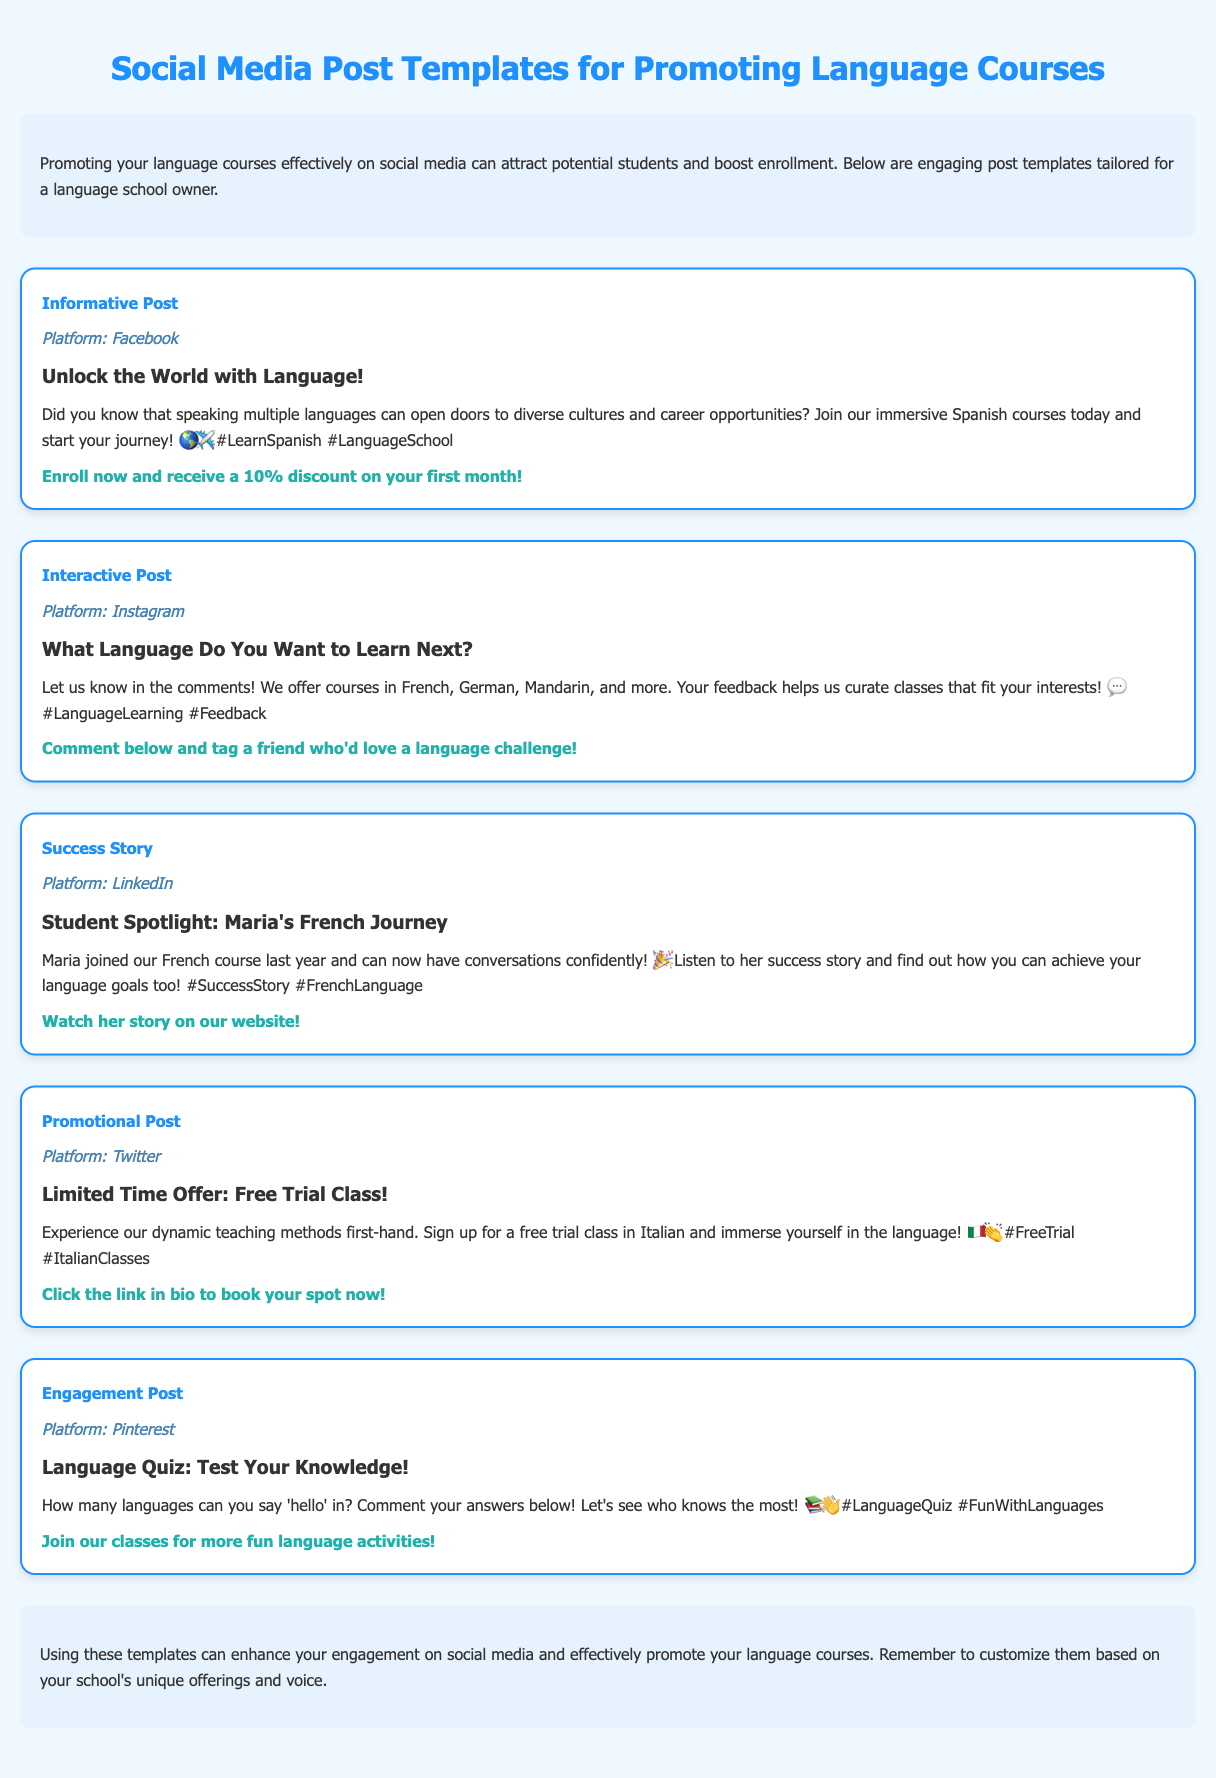What is the title of the document? The title of the document is specified in the `<title>` tag at the beginning.
Answer: Social Media Post Templates for Language Courses How many post templates are provided? The document contains five separate post templates, each described in detail.
Answer: 5 What is the platform for the Informative Post? The platform is indicated in the post template section for the Informative Post.
Answer: Facebook What is the call-to-action in the Promotional Post? The call-to-action is given at the end of each post template, specifically for the Promotional Post.
Answer: Click the link in bio to book your spot now! What language can one sign up for in the free trial class? The specified language for the free trial class is mentioned within the body of the Promotional Post.
Answer: Italian What is the headline of the Success Story post? The headline is presented prominently in the Success Story post template.
Answer: Student Spotlight: Maria's French Journey Which social media platform is used for interactive engagement in the post? The document indicates the platform for the Interactive Post.
Answer: Instagram What type of post encourages comments about language preferences? The type of post that engages users to comment is described in the post template section.
Answer: Interactive Post 